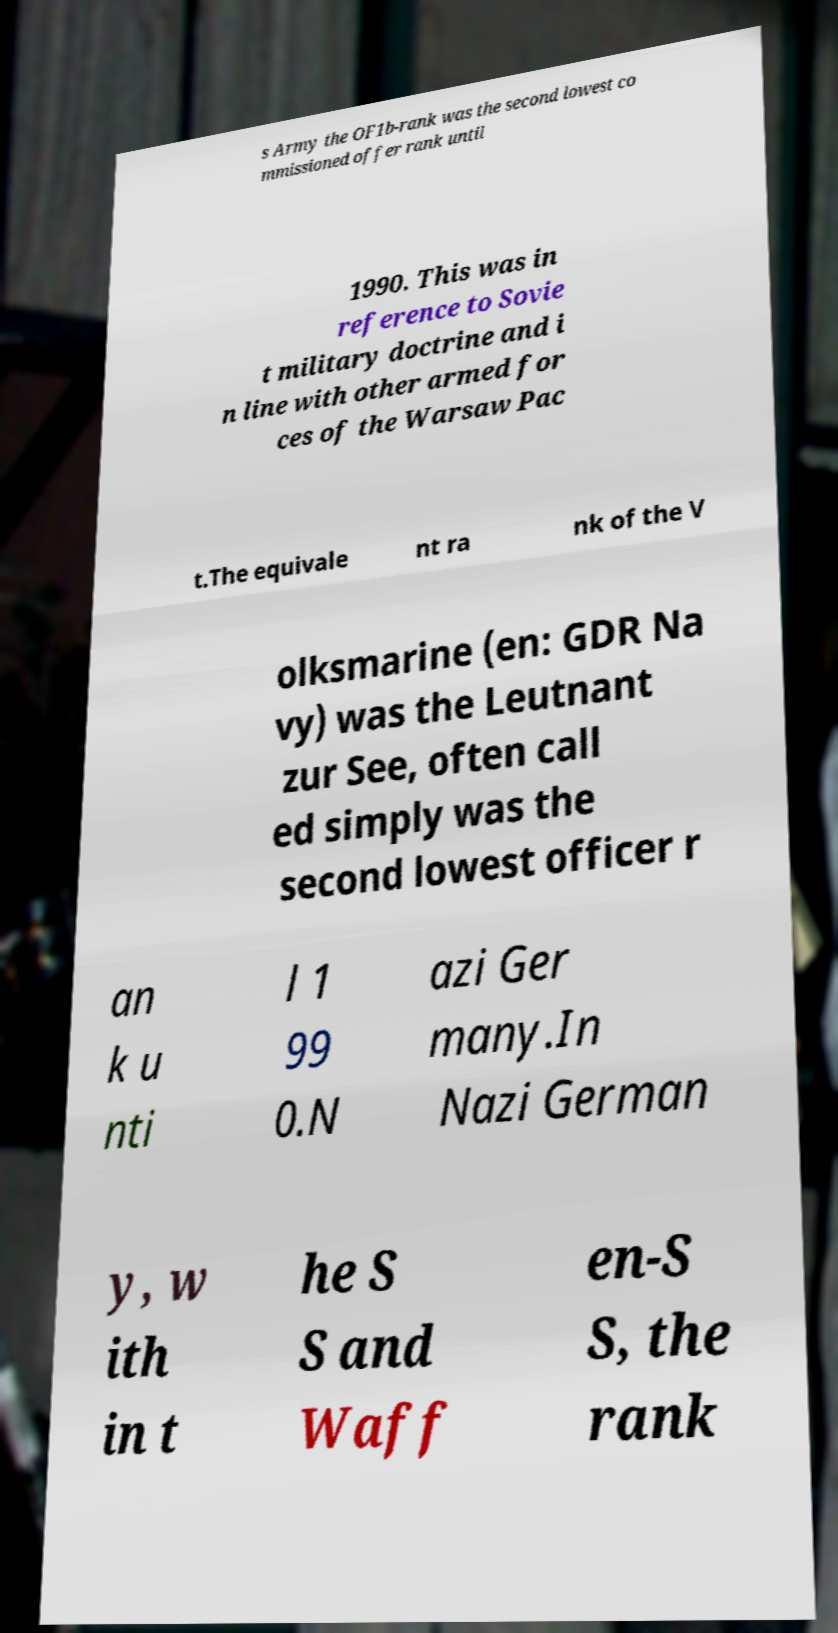For documentation purposes, I need the text within this image transcribed. Could you provide that? s Army the OF1b-rank was the second lowest co mmissioned offer rank until 1990. This was in reference to Sovie t military doctrine and i n line with other armed for ces of the Warsaw Pac t.The equivale nt ra nk of the V olksmarine (en: GDR Na vy) was the Leutnant zur See, often call ed simply was the second lowest officer r an k u nti l 1 99 0.N azi Ger many.In Nazi German y, w ith in t he S S and Waff en-S S, the rank 